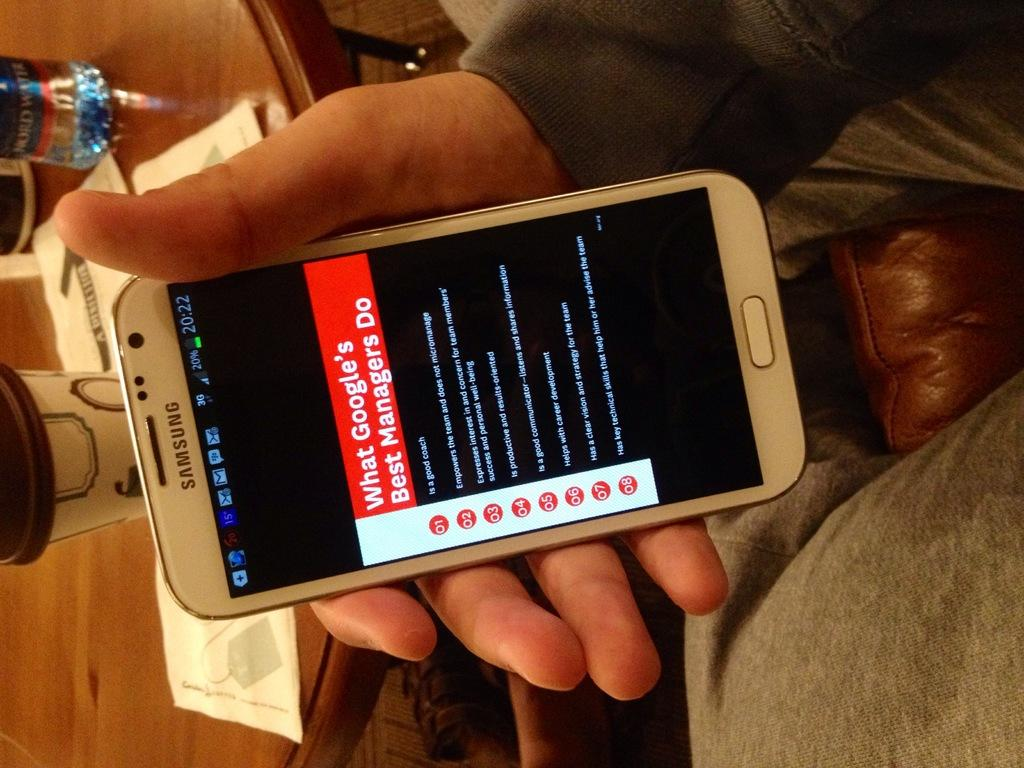<image>
Provide a brief description of the given image. Someone is holding a samsung smartphone while sitting on a chair. 